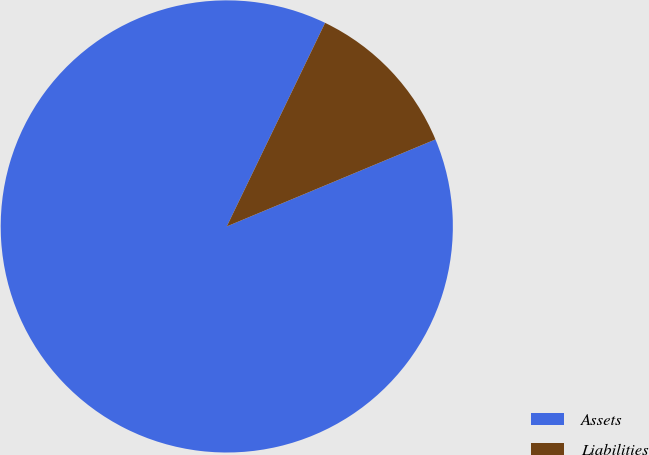Convert chart. <chart><loc_0><loc_0><loc_500><loc_500><pie_chart><fcel>Assets<fcel>Liabilities<nl><fcel>88.45%<fcel>11.55%<nl></chart> 